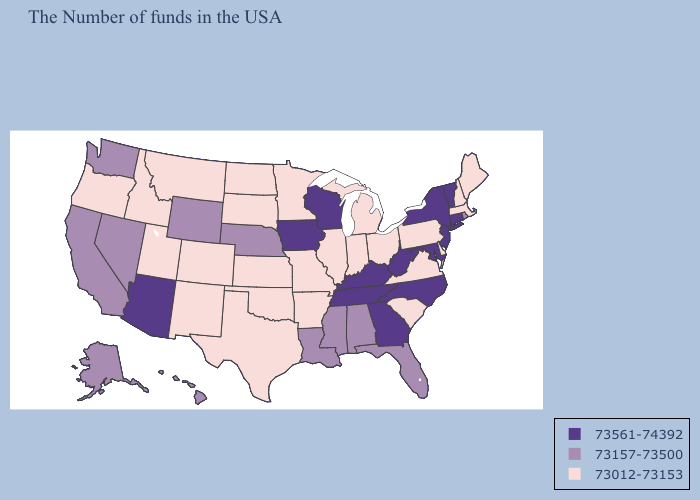Does the map have missing data?
Keep it brief. No. Name the states that have a value in the range 73561-74392?
Write a very short answer. Vermont, Connecticut, New York, New Jersey, Maryland, North Carolina, West Virginia, Georgia, Kentucky, Tennessee, Wisconsin, Iowa, Arizona. Which states have the highest value in the USA?
Write a very short answer. Vermont, Connecticut, New York, New Jersey, Maryland, North Carolina, West Virginia, Georgia, Kentucky, Tennessee, Wisconsin, Iowa, Arizona. Does the first symbol in the legend represent the smallest category?
Give a very brief answer. No. Name the states that have a value in the range 73157-73500?
Write a very short answer. Rhode Island, Florida, Alabama, Mississippi, Louisiana, Nebraska, Wyoming, Nevada, California, Washington, Alaska, Hawaii. What is the value of Oregon?
Give a very brief answer. 73012-73153. Among the states that border Wisconsin , which have the lowest value?
Give a very brief answer. Michigan, Illinois, Minnesota. How many symbols are there in the legend?
Concise answer only. 3. Is the legend a continuous bar?
Answer briefly. No. Which states hav the highest value in the South?
Concise answer only. Maryland, North Carolina, West Virginia, Georgia, Kentucky, Tennessee. Name the states that have a value in the range 73012-73153?
Be succinct. Maine, Massachusetts, New Hampshire, Delaware, Pennsylvania, Virginia, South Carolina, Ohio, Michigan, Indiana, Illinois, Missouri, Arkansas, Minnesota, Kansas, Oklahoma, Texas, South Dakota, North Dakota, Colorado, New Mexico, Utah, Montana, Idaho, Oregon. What is the value of North Carolina?
Give a very brief answer. 73561-74392. Name the states that have a value in the range 73157-73500?
Concise answer only. Rhode Island, Florida, Alabama, Mississippi, Louisiana, Nebraska, Wyoming, Nevada, California, Washington, Alaska, Hawaii. Name the states that have a value in the range 73561-74392?
Be succinct. Vermont, Connecticut, New York, New Jersey, Maryland, North Carolina, West Virginia, Georgia, Kentucky, Tennessee, Wisconsin, Iowa, Arizona. Does Arizona have the highest value in the West?
Write a very short answer. Yes. 